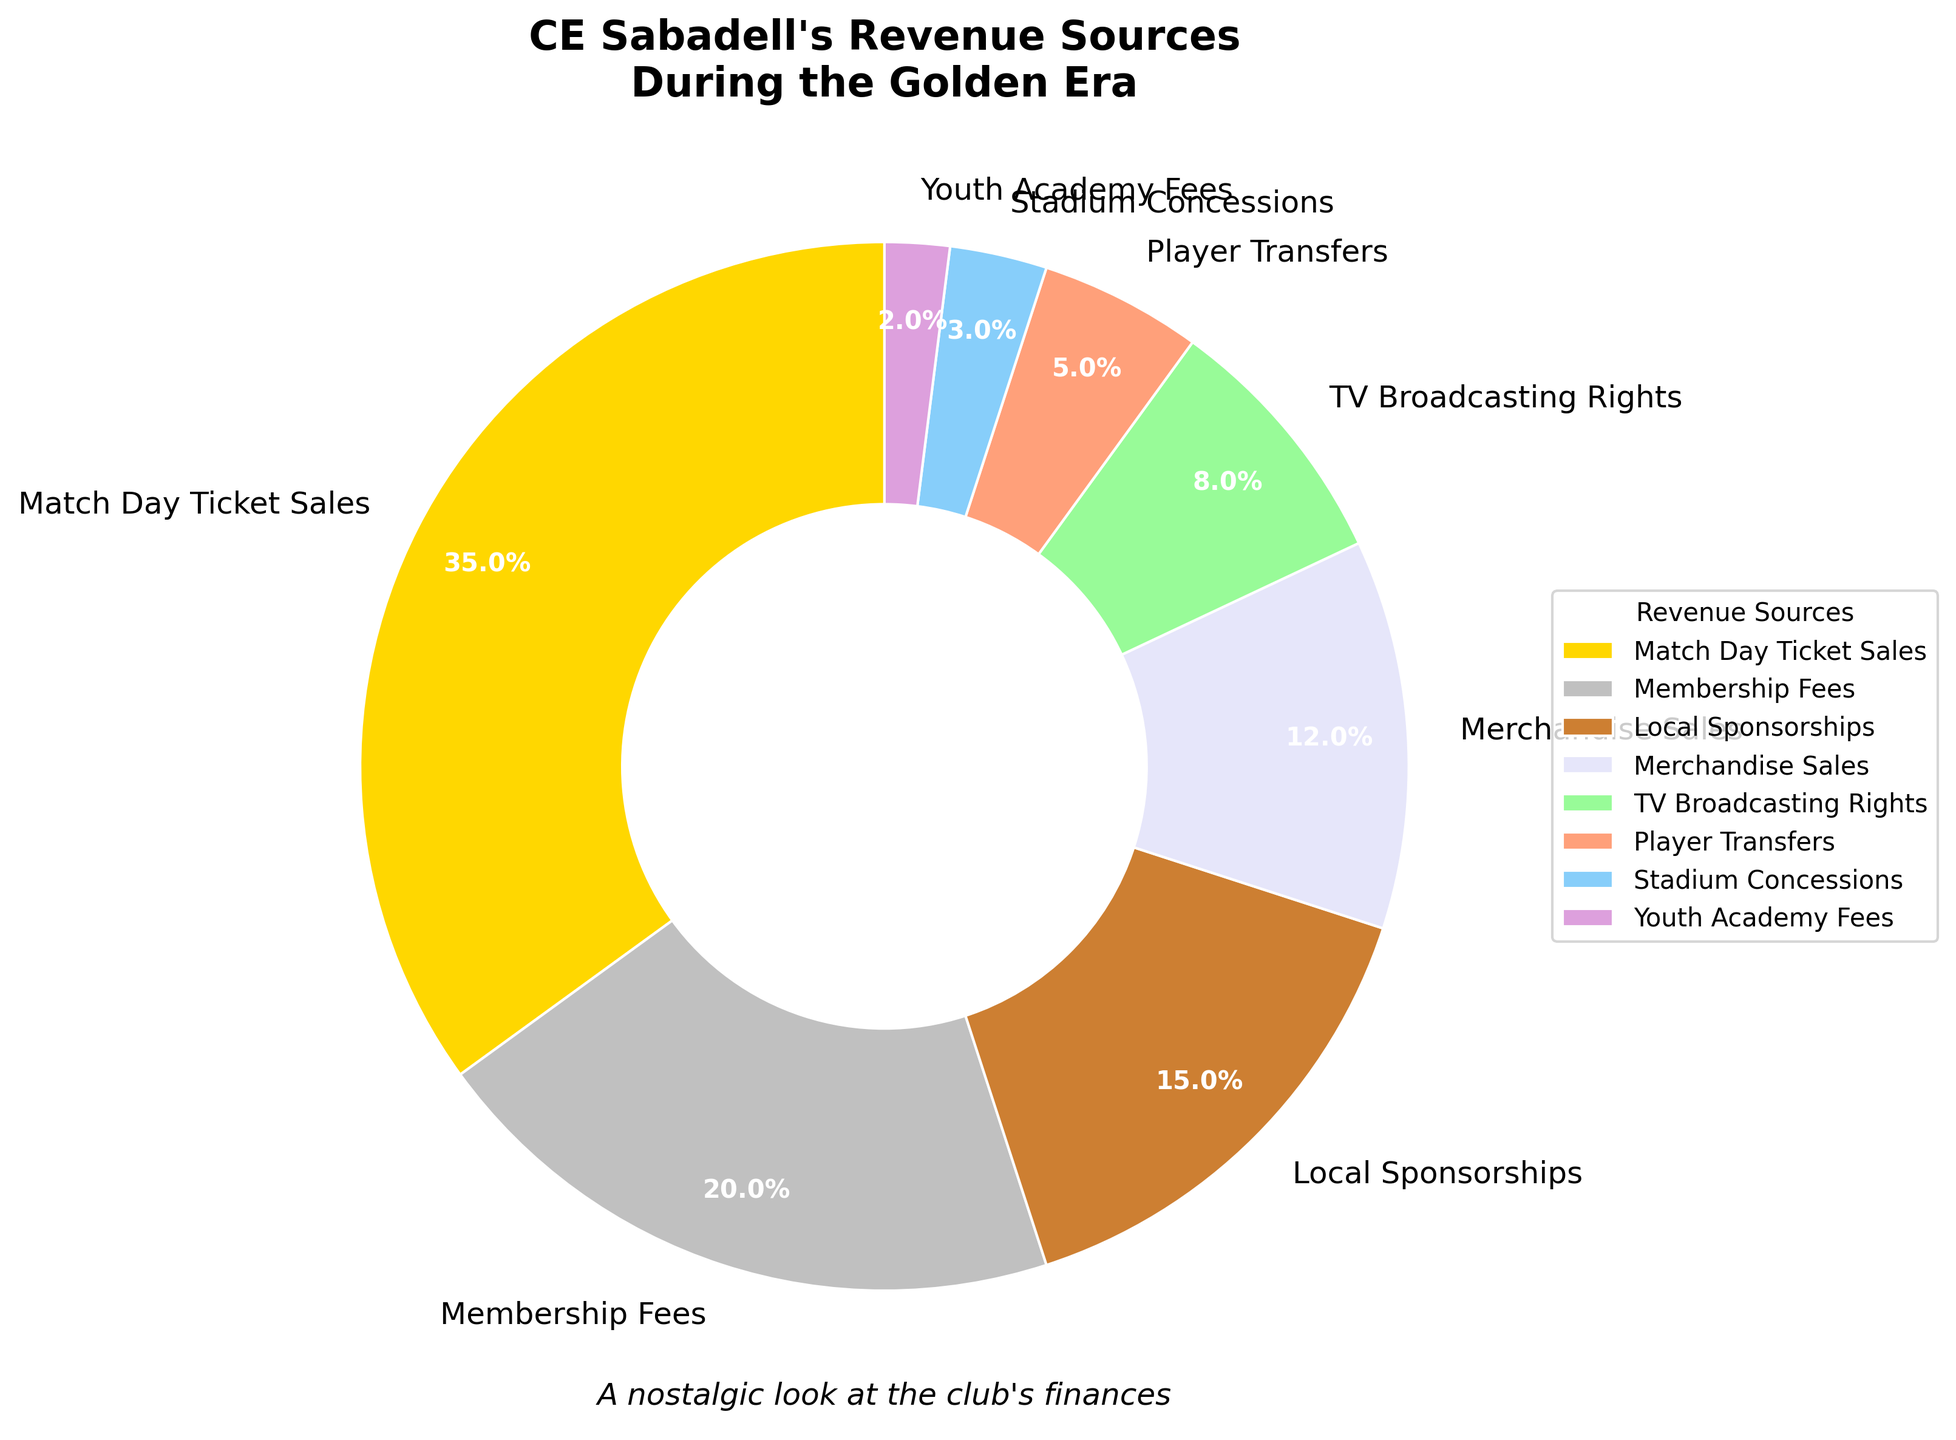What are the two largest revenue sources for CE Sabadell during the golden era? The chart shows that Match Day Ticket Sales and Membership Fees are the largest wedges, making up 35% and 20% of the revenue, respectively.
Answer: Match Day Ticket Sales and Membership Fees Which revenue source contributes the least to the total revenue? By observing the smallest wedge in the pie chart, it is clear that Youth Academy Fees, with a percentage of 2%, contributes the least.
Answer: Youth Academy Fees Are the combined revenues from TV Broadcasting Rights and Player Transfers greater than the revenue from Local Sponsorships? Adding the percentages of TV Broadcasting Rights (8%) and Player Transfers (5%) gives 13%, which is less than the 15% from Local Sponsorships.
Answer: No Comparing Merchandise Sales and Stadium Concessions, which one is larger, and by how much? Merchandise Sales at 12% is larger than Stadium Concessions at 3%. The difference is 12% - 3% = 9%.
Answer: Merchandise Sales by 9% What is the total percentage of revenue from Match Day Ticket Sales, Local Sponsorships, and Youth Academy Fees combined? Adding the percentages: Match Day Ticket Sales (35%), Local Sponsorships (15%), and Youth Academy Fees (2%) gives a total of 35 + 15 + 2 = 52%.
Answer: 52% Is the revenue from Membership Fees greater than the sum of Player Transfers and Stadium Concessions? Membership Fees contribute 20%, while Player Transfers and Stadium Concessions together sum to 5% + 3% = 8%. Since 20% is greater than 8%, the answer is yes.
Answer: Yes What is the percentage difference between Match Day Ticket Sales and TV Broadcasting Rights? Subtracting the percentage of TV Broadcasting Rights (8%) from Match Day Ticket Sales (35%) gives a difference of 35 - 8 = 27%.
Answer: 27% How does the revenue from Merchandise Sales compare to the sum of Youth Academy Fees and Stadium Concessions? Adding the percentages of Youth Academy Fees (2%) and Stadium Concessions (3%) results in 2% + 3% = 5%. Comparing this to Merchandise Sales at 12%, you can see that Merchandise Sales is larger.
Answer: Merchandise Sales is larger What percentage of the total revenue is generated from non-match day activities (excluding Match Day Ticket Sales)? Subtracting the Match Day Ticket Sales percentage (35%) from 100% gives 100% - 35% = 65%.
Answer: 65% If you combined the revenue from the two smallest sources, what would the new percentage be, and would it be larger than Player Transfers? Combining Youth Academy Fees (2%) and Stadium Concessions (3%) gives 2% + 3% = 5%. The result is equal to the percentage from Player Transfers.
Answer: 5%, and it would be equal 